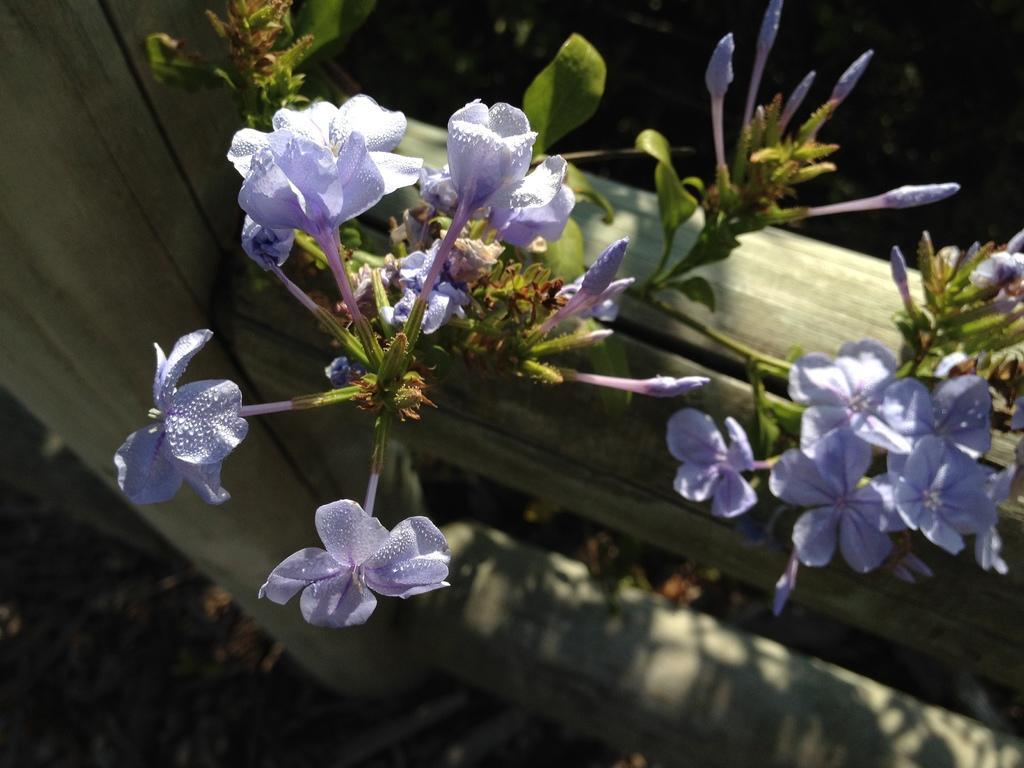In one or two sentences, can you explain what this image depicts? In the image there are few plants and there are beautiful flowers to the plants. 